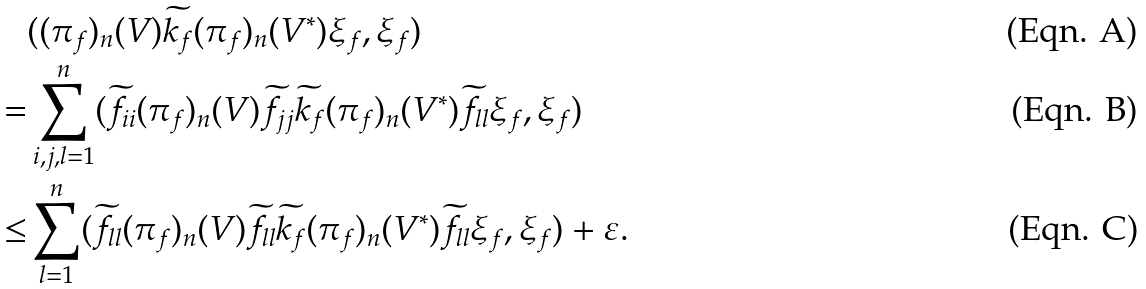<formula> <loc_0><loc_0><loc_500><loc_500>& ( ( \pi _ { f } ) _ { n } ( V ) \widetilde { k _ { f } } ( \pi _ { f } ) _ { n } ( V ^ { * } ) \xi _ { f } , \xi _ { f } ) & \\ = & \sum _ { i , j , l = 1 } ^ { n } ( \widetilde { f _ { i i } } ( \pi _ { f } ) _ { n } ( V ) \widetilde { f _ { j j } } \widetilde { k _ { f } } ( \pi _ { f } ) _ { n } ( V ^ { * } ) \widetilde { f _ { l l } } \xi _ { f } , \xi _ { f } ) & \\ \leq & \sum _ { l = 1 } ^ { n } ( \widetilde { f _ { l l } } ( \pi _ { f } ) _ { n } ( V ) \widetilde { f _ { l l } } \widetilde { k _ { f } } ( \pi _ { f } ) _ { n } ( V ^ { * } ) \widetilde { f _ { l l } } \xi _ { f } , \xi _ { f } ) + \varepsilon . &</formula> 